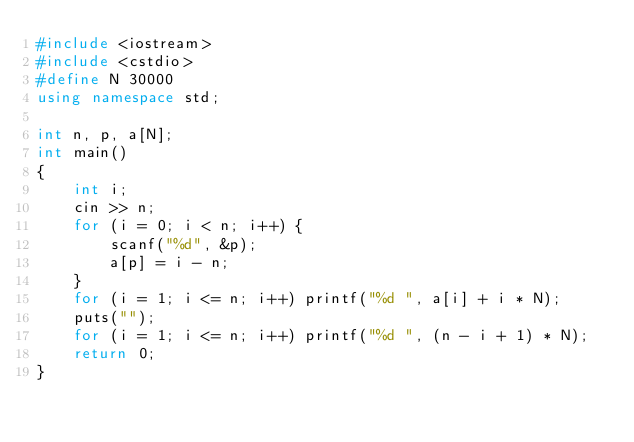<code> <loc_0><loc_0><loc_500><loc_500><_C++_>#include <iostream>
#include <cstdio>
#define N 30000
using namespace std;

int n, p, a[N];
int main()
{
	int i;
	cin >> n;
	for (i = 0; i < n; i++) {
		scanf("%d", &p);
		a[p] = i - n;
	}
	for (i = 1; i <= n; i++) printf("%d ", a[i] + i * N);
	puts("");
	for (i = 1; i <= n; i++) printf("%d ", (n - i + 1) * N);
    return 0;
}</code> 